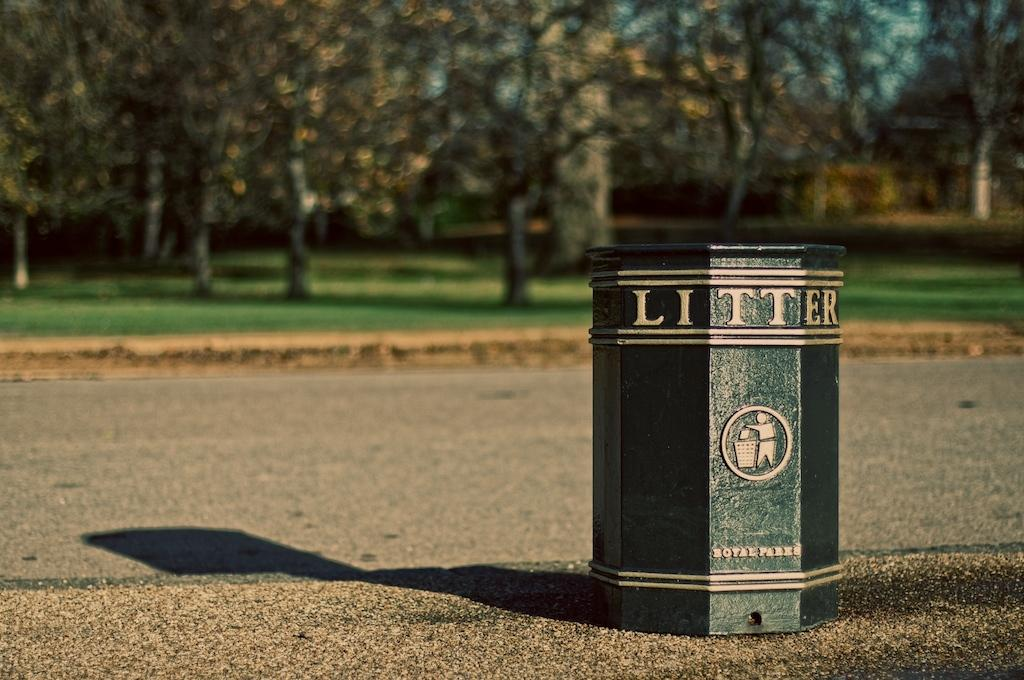<image>
Describe the image concisely. Green trash can which says LITTER on it. 